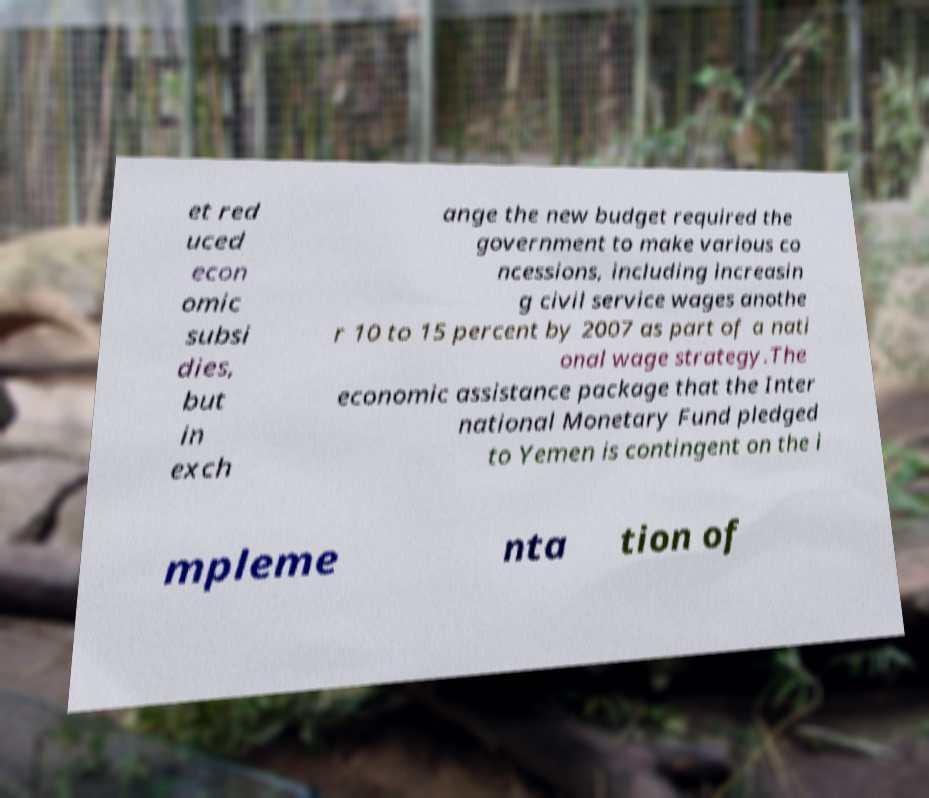Please read and relay the text visible in this image. What does it say? et red uced econ omic subsi dies, but in exch ange the new budget required the government to make various co ncessions, including increasin g civil service wages anothe r 10 to 15 percent by 2007 as part of a nati onal wage strategy.The economic assistance package that the Inter national Monetary Fund pledged to Yemen is contingent on the i mpleme nta tion of 